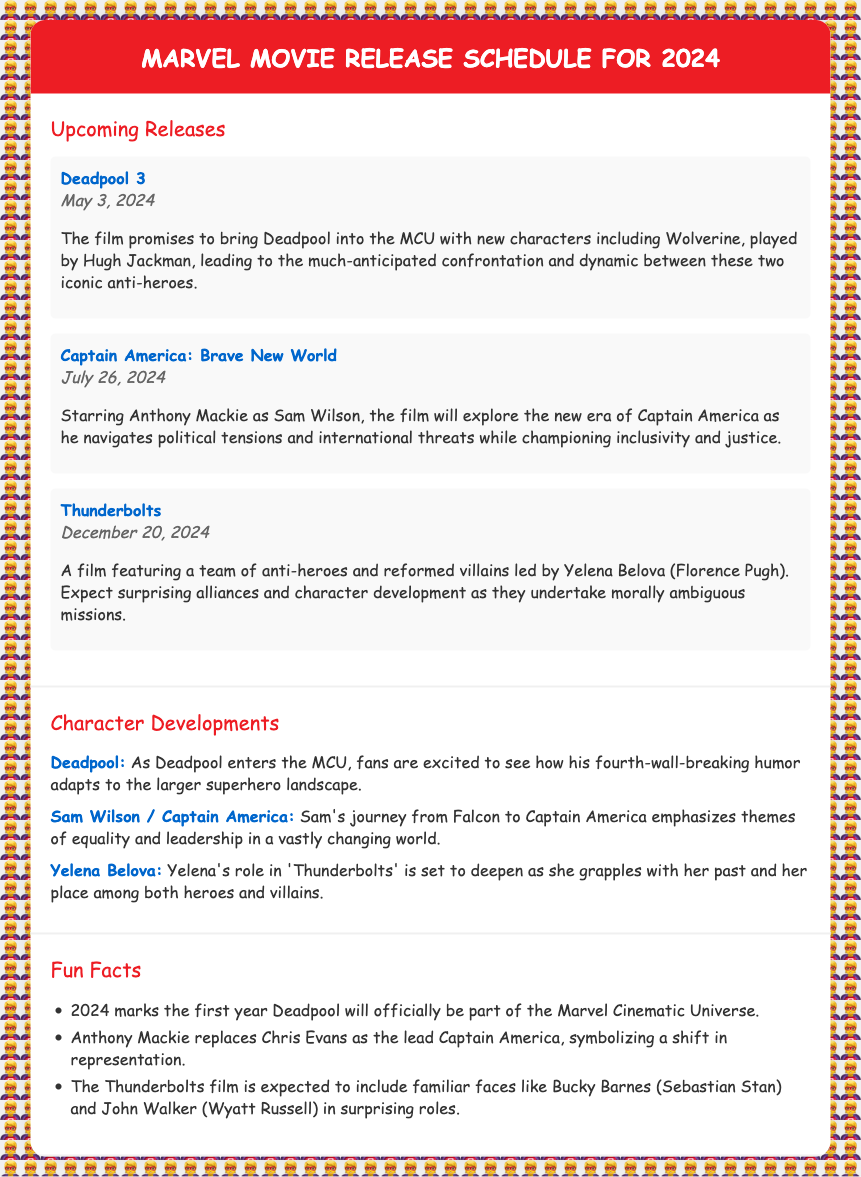What is the release date of Deadpool 3? The release date is explicitly mentioned in the document as May 3, 2024.
Answer: May 3, 2024 Who plays Wolverine in Deadpool 3? The document specifies that Wolverine is played by Hugh Jackman.
Answer: Hugh Jackman What is the title of the film featuring Sam Wilson as Captain America? The document clearly states that the film is called "Captain America: Brave New World."
Answer: Captain America: Brave New World Which character leads the Thunderbolts team? The document indicates that Yelena Belova leads the Thunderbolts.
Answer: Yelena Belova What significant transition does Sam Wilson undergo in his film? The document explains that Sam Wilson transitions from Falcon to Captain America.
Answer: Falcon to Captain America Which Marvel movie marks the official entry of Deadpool into the MCU? The document notes that 2024 marks the first year Deadpool will officially be part of the Marvel Cinematic Universe.
Answer: Deadpool 3 In which film will Bucky Barnes and John Walker appear? The document mentions that these characters are expected to appear in the Thunderbolts film.
Answer: Thunderbolts What overarching theme is highlighted in Sam Wilson's journey? The document describes themes of equality and leadership as key aspects of Sam's journey.
Answer: Equality and leadership 